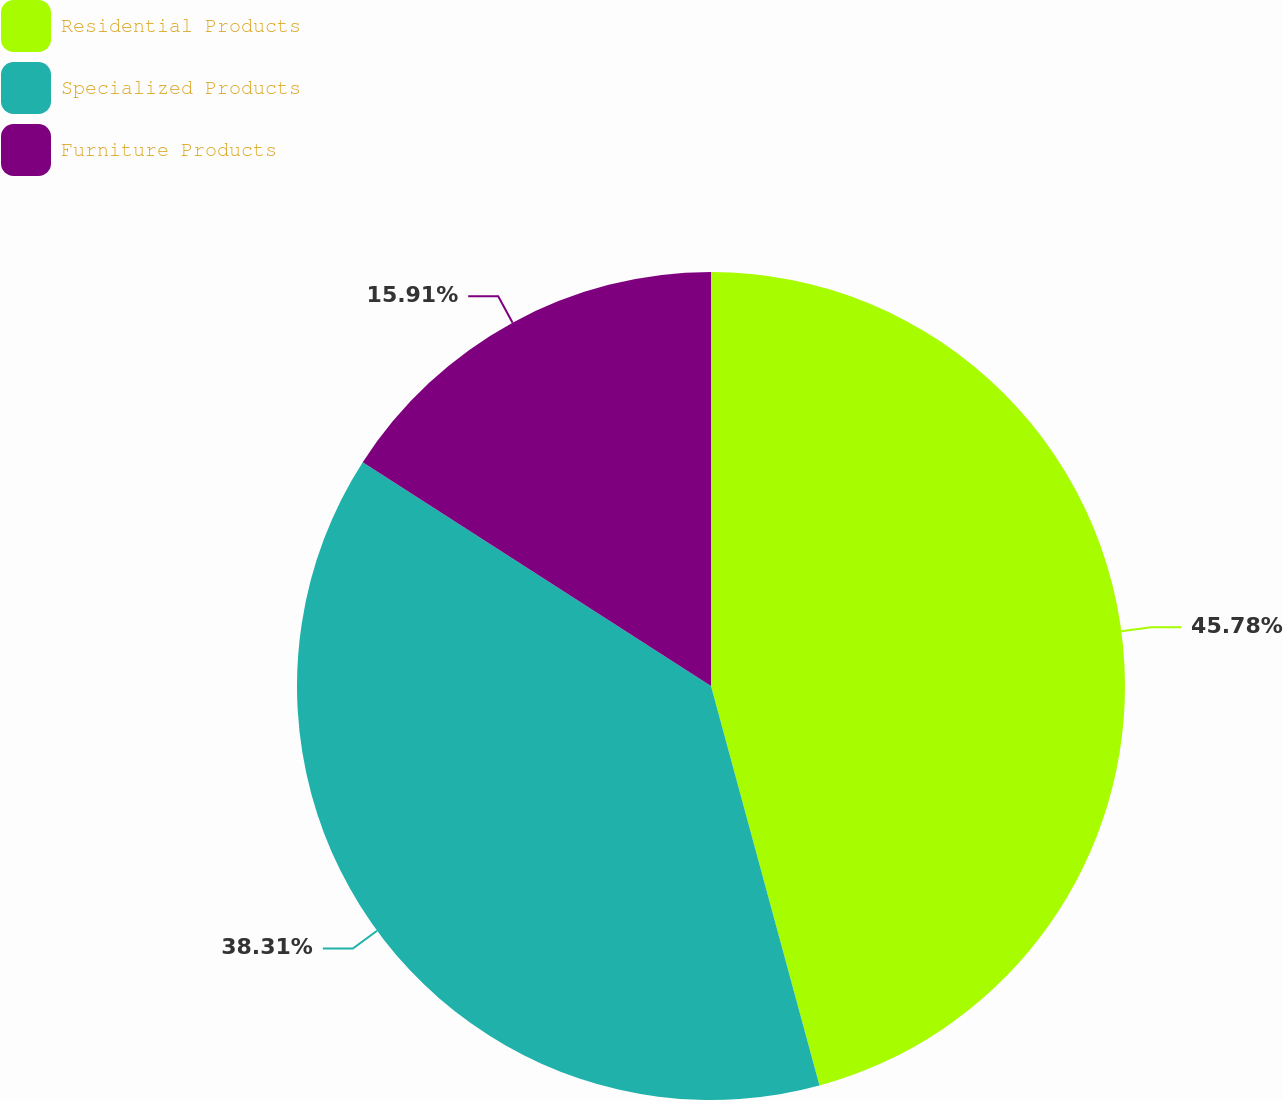Convert chart. <chart><loc_0><loc_0><loc_500><loc_500><pie_chart><fcel>Residential Products<fcel>Specialized Products<fcel>Furniture Products<nl><fcel>45.78%<fcel>38.31%<fcel>15.91%<nl></chart> 